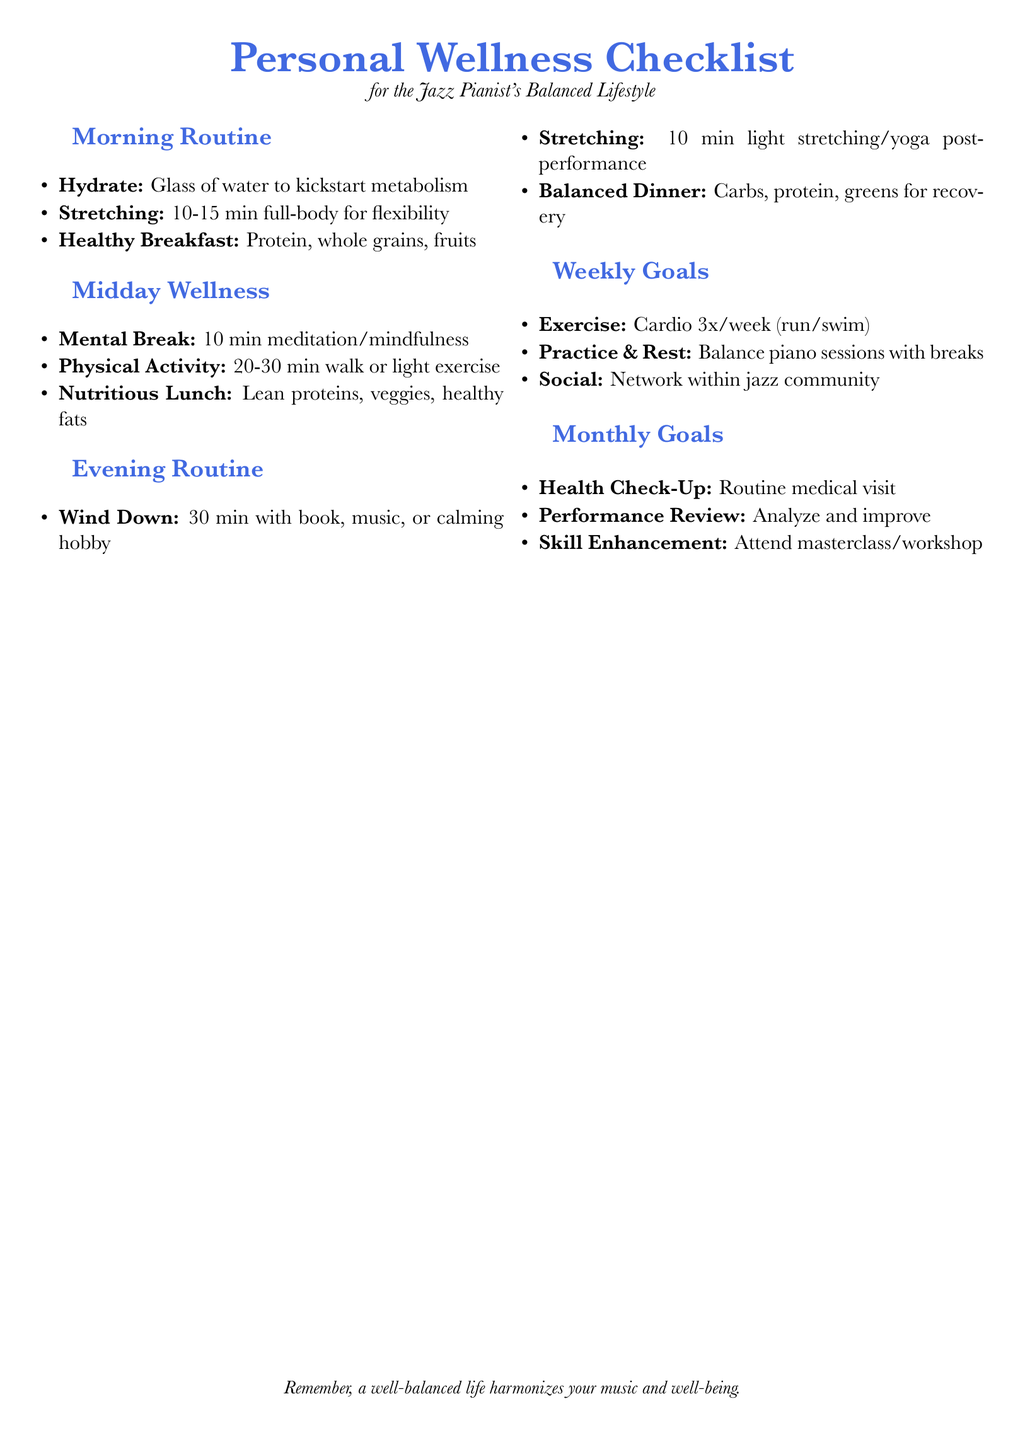What is the main title of the document? The main title is prominently displayed at the top of the document, indicating the focus on personal wellness.
Answer: Personal Wellness Checklist How much time is suggested for stretching in the morning routine? The checklist specifies the time allocated for stretching in the morning routine section.
Answer: 10-15 min How many times per week is cardio recommended? The weekly goals section includes a recommendation for cardio frequency.
Answer: 3x/week What kind of exercise is suggested for midday physical activity? This describes the type of physical activity recommended during the midday wellness section.
Answer: walk or light exercise What is the suggested activity for winding down in the evening routine? The document outlines a specific activity to help with wind down in the evening.
Answer: book, music, or calming hobby How often should one attend a health check-up according to the monthly goals? The document provides an indication of how frequently a health check-up is suggested.
Answer: Routine What food types are recommended for a balanced dinner? This is found in the evening routine section, focusing on the composition of a balanced dinner.
Answer: Carbs, protein, greens What type of community engagement is encouraged in the weekly goals? The weekly goals highlight social interaction within a specific group.
Answer: network within jazz community What kind of enhancement is suggested in the monthly goals? This part of the document emphasizes opportunities for personal growth and skill improvement.
Answer: Skill Enhancement 